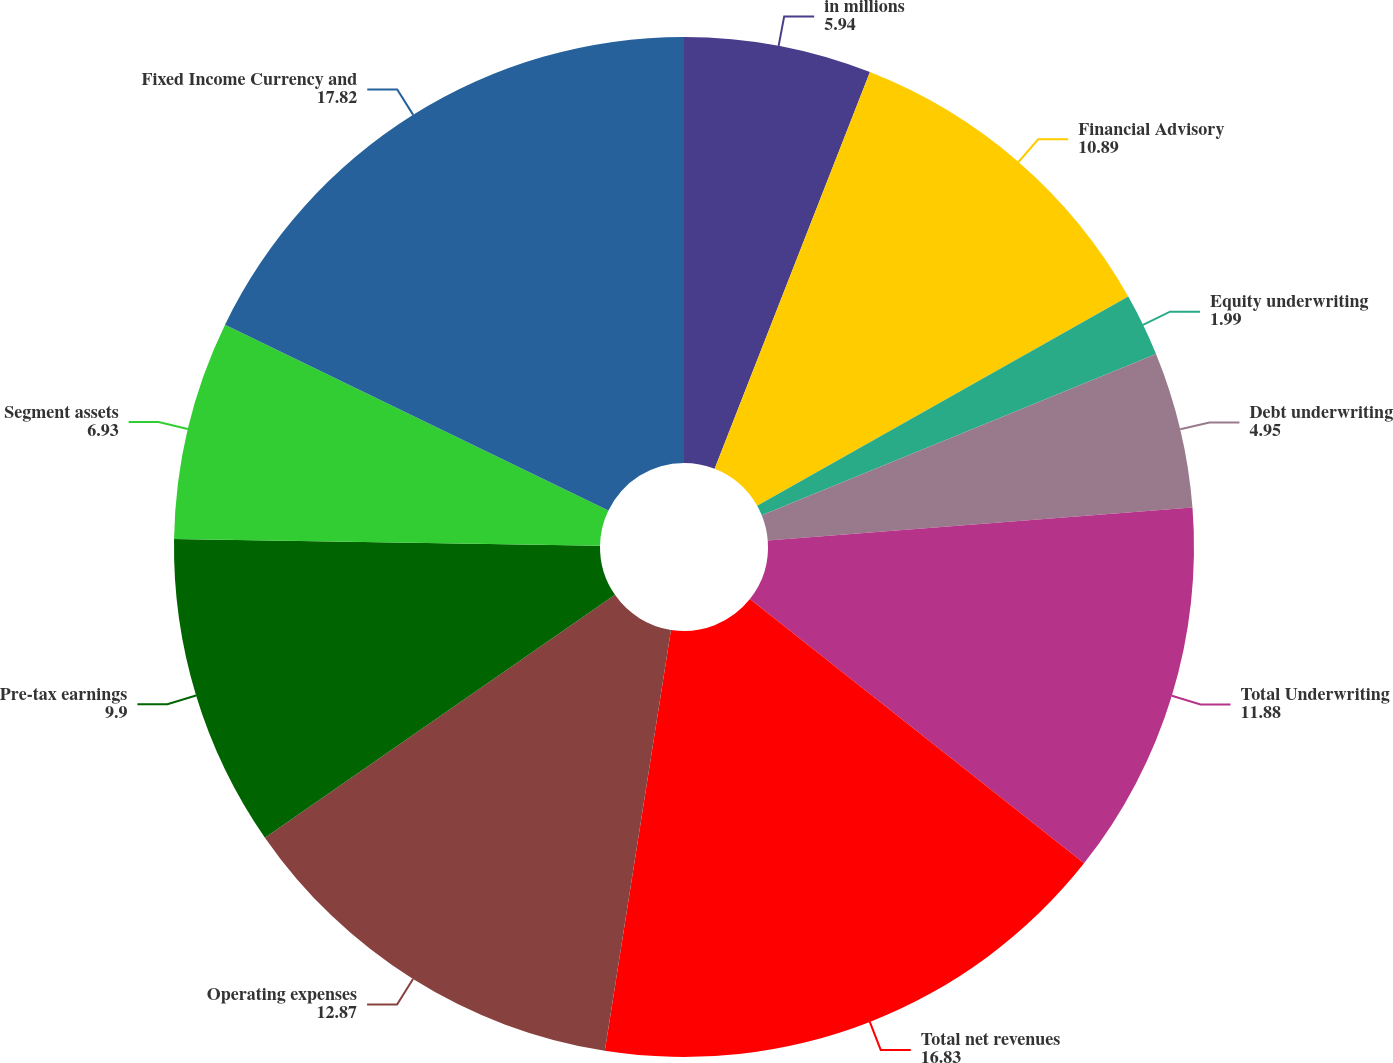<chart> <loc_0><loc_0><loc_500><loc_500><pie_chart><fcel>in millions<fcel>Financial Advisory<fcel>Equity underwriting<fcel>Debt underwriting<fcel>Total Underwriting<fcel>Total net revenues<fcel>Operating expenses<fcel>Pre-tax earnings<fcel>Segment assets<fcel>Fixed Income Currency and<nl><fcel>5.94%<fcel>10.89%<fcel>1.99%<fcel>4.95%<fcel>11.88%<fcel>16.83%<fcel>12.87%<fcel>9.9%<fcel>6.93%<fcel>17.82%<nl></chart> 